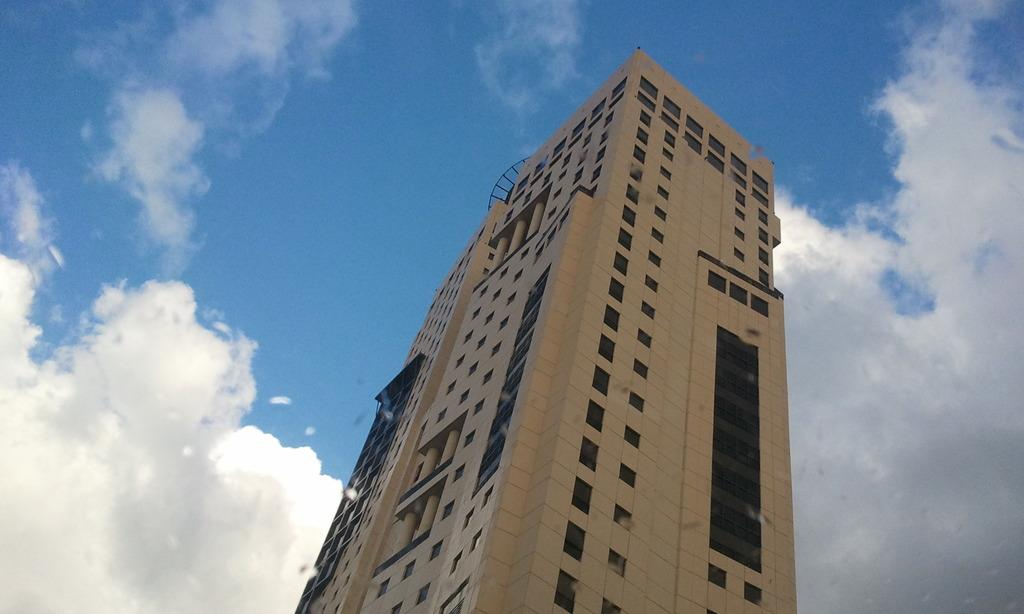What type of structure is present in the image? There is a building in the image. What can be seen in the background of the image? The sky is visible in the background of the image. What type of flowers are being shown in the image? There are no flowers present in the image. What story is being told in the image? The image does not depict a story; it simply shows a building and the sky. 